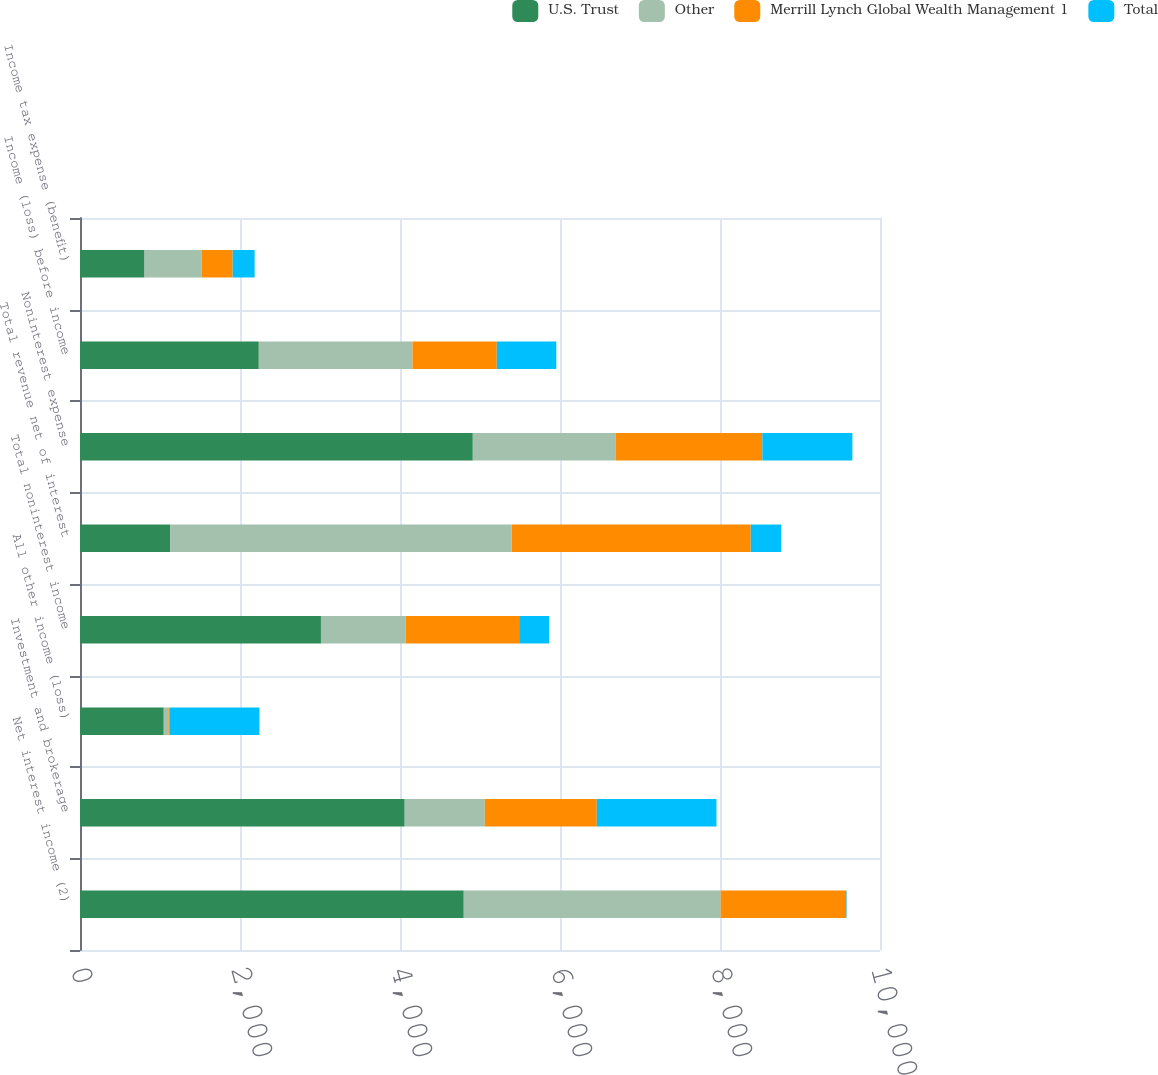<chart> <loc_0><loc_0><loc_500><loc_500><stacked_bar_chart><ecel><fcel>Net interest income (2)<fcel>Investment and brokerage<fcel>All other income (loss)<fcel>Total noninterest income<fcel>Total revenue net of interest<fcel>Noninterest expense<fcel>Income (loss) before income<fcel>Income tax expense (benefit)<nl><fcel>U.S. Trust<fcel>4797<fcel>4059<fcel>1047<fcel>3012<fcel>1126<fcel>4910<fcel>2235<fcel>807<nl><fcel>Other<fcel>3211<fcel>1001<fcel>58<fcel>1059<fcel>4270<fcel>1788<fcel>1921<fcel>711<nl><fcel>Merrill Lynch Global Wealth Management 1<fcel>1570<fcel>1400<fcel>18<fcel>1418<fcel>2988<fcel>1831<fcel>1054<fcel>390<nl><fcel>Total<fcel>6<fcel>1496<fcel>1120<fcel>376<fcel>382<fcel>1126<fcel>744<fcel>275<nl></chart> 